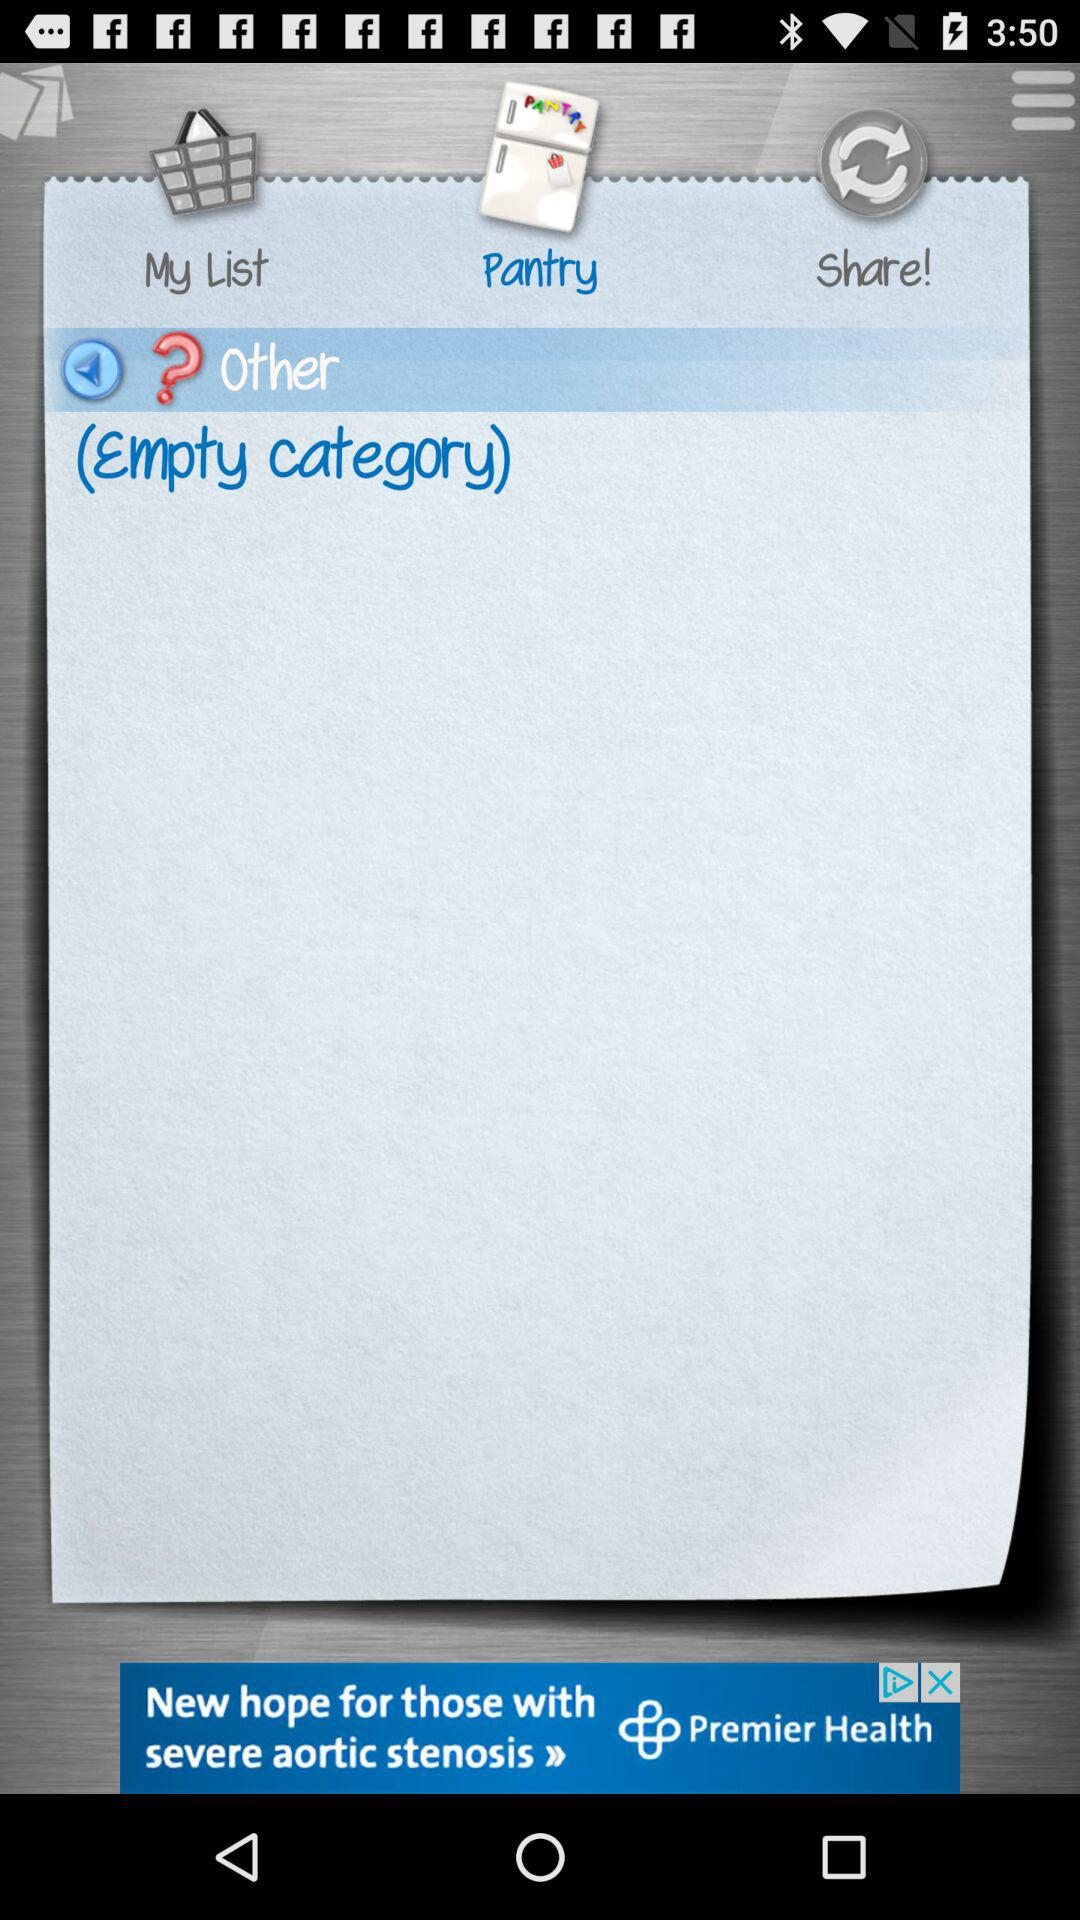How many empty categories are there?
Answer the question using a single word or phrase. 1 